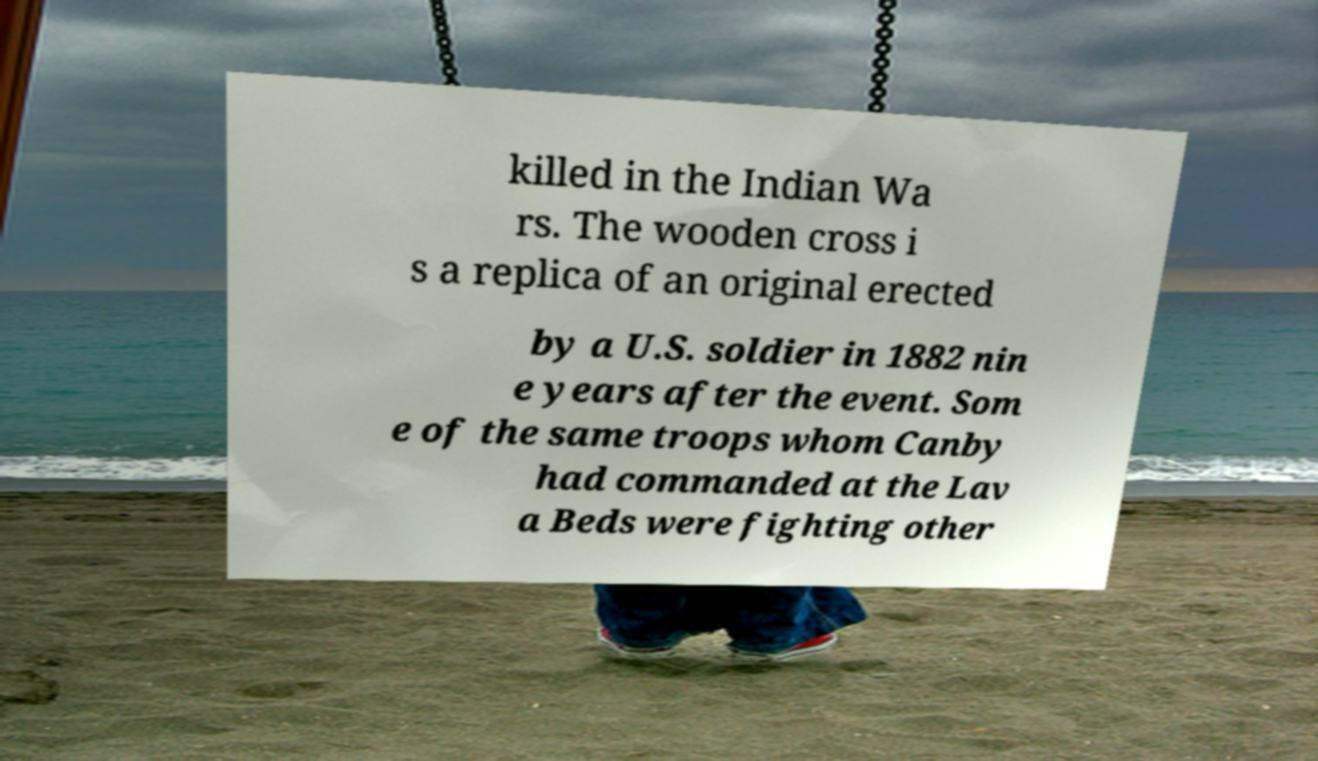Could you extract and type out the text from this image? killed in the Indian Wa rs. The wooden cross i s a replica of an original erected by a U.S. soldier in 1882 nin e years after the event. Som e of the same troops whom Canby had commanded at the Lav a Beds were fighting other 